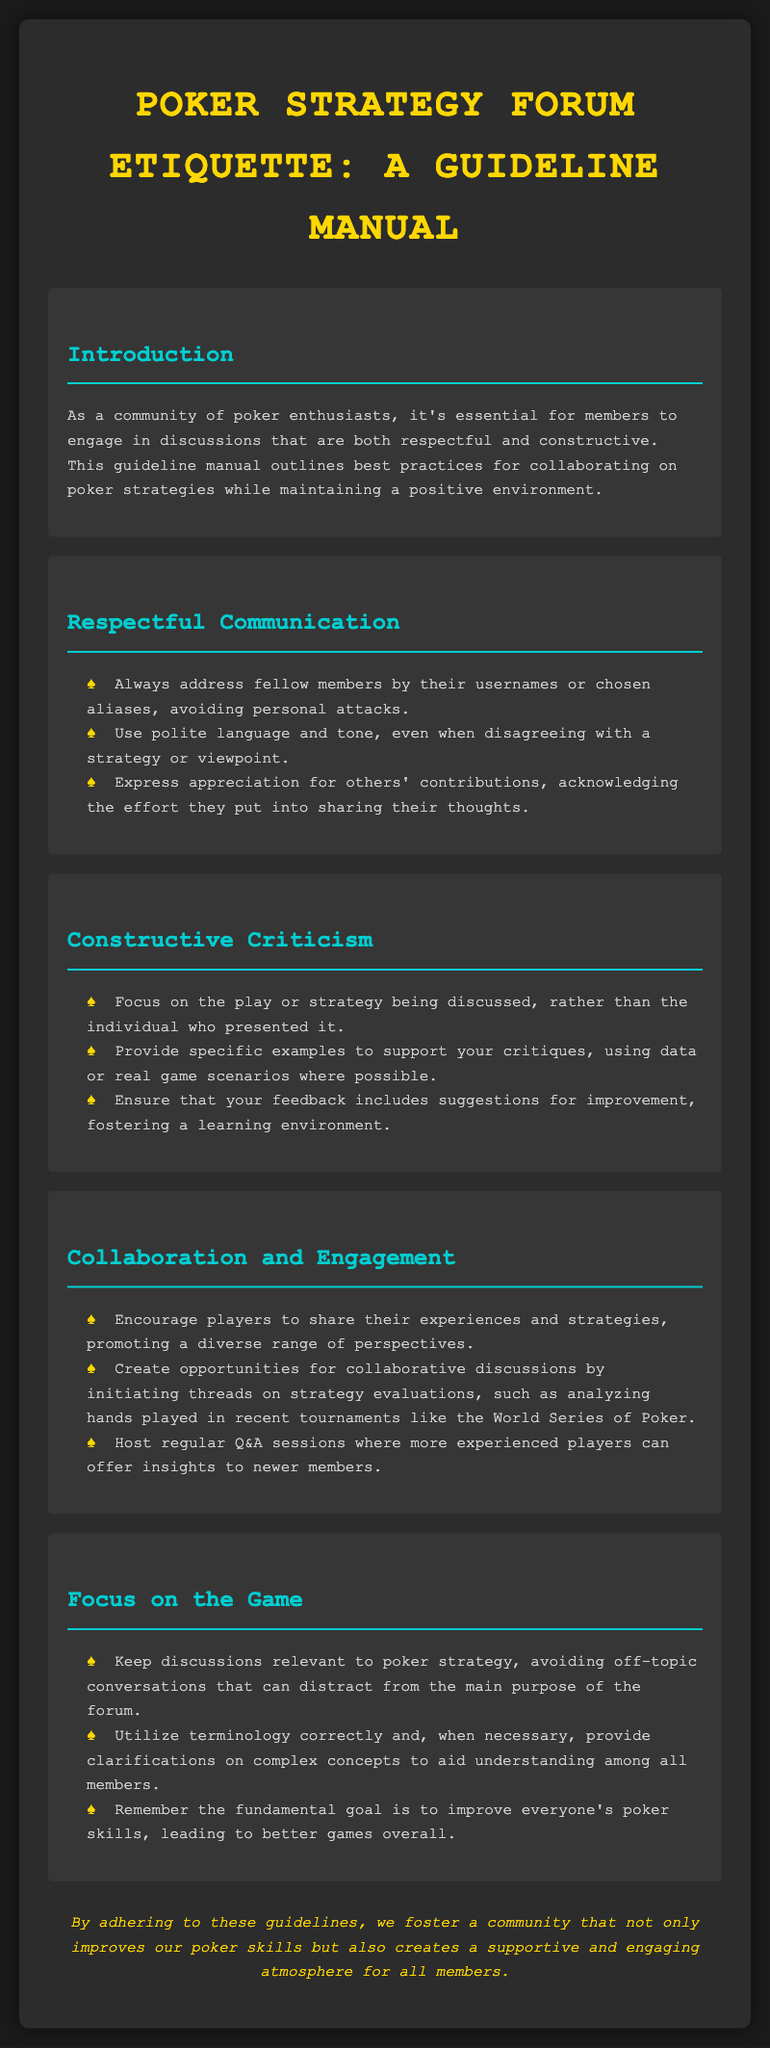What is the title of the document? The title is prominently displayed at the top of the document, which is "Poker Strategy Forum Etiquette: A Guideline Manual."
Answer: Poker Strategy Forum Etiquette: A Guideline Manual How many sections are listed in the document? The document contains several sections listed under headings, specifically five distinct sections.
Answer: Five What color is used for the section titles? The section titles are formatted with a specific color, which is indicated as #00ced1 in the style.
Answer: #00ced1 What should members express appreciation for? The document encourages members to acknowledge and appreciate the effort others put into sharing their thoughts.
Answer: Others' contributions What is the primary goal mentioned in the document? The document states that the fundamental goal is to improve everyone's poker skills.
Answer: Improve everyone's poker skills What does the document promote among players? The guidelines emphasize collaboration among members through sharing experiences and strategies.
Answer: Collaboration What type of sessions does the document suggest hosting? The document proposes hosting regular Q&A sessions for sharing insights, especially for newer members.
Answer: Q&A sessions What is the overall tone encouraged in communications? The guidelines advocate for a tone that is polite, even during disagreements about strategies.
Answer: Polite 